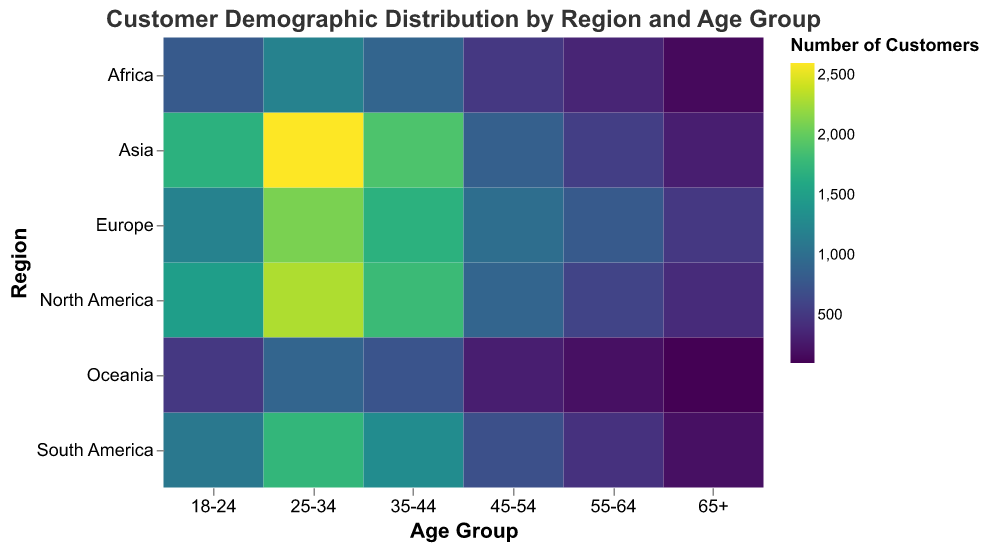What is the title of the heatmap? The title is located at the top of the heatmap and reads "Customer Demographic Distribution by Region and Age Group".
Answer: Customer Demographic Distribution by Region and Age Group Which region has the highest number of customers for the 25-34 age group? By looking at the intersection of the '25-34' age group and different regions on the y-axis, Asia has the darkest shade, indicating the highest number of customers for this age group.
Answer: Asia How many customers are in the 45-54 age group for Europe? To find this, locate the cell where the '45-54' age group column intersects with the 'Europe' row. The number in the cell is 1000.
Answer: 1000 Among the different regions, which has the smallest number of customers in the 65+ age group? By locating the '65+' column and comparing shades across the regions, Oceania has the lightest shade, indicating the smallest number of customers, which is 100.
Answer: Oceania What is the total number of customers for the 18-24 age group across all regions? Sum the number of customers for the '18-24' age group from each region: 1500 (North America) + 1200 (Europe) + 1700 (Asia) + 1100 (South America) + 800 (Africa) + 500 (Oceania) = 6800.
Answer: 6800 Which age group in North America has the fewest customers? Check the 'North America' row and identify the age group with the lightest shade. The '65+' age group has the fewest customers with 400.
Answer: 65+ Compare the number of customers in the 25-34 age group between Africa and South America. Which region has more customers? Compare the numbers in the '25-34' column for Africa (1200) and South America (1750). South America has more customers.
Answer: South America What is the average number of customers for the 35-44 age group across Asia, Europe, and North America? Sum the number of customers for the '35-44' age group in Asia (1900), Europe (1700), and North America (1800). The total is 5400. Then divide by 3: 5400 / 3 = 1800.
Answer: 1800 What is the trend in the number of customers as age increases in South America? Observe the cells in the 'South America' row from left to right. Generally, the number of customers decreases as age increases.
Answer: Decreasing Which age group has the highest number of customers in Asia, and how many? Identify the darkest cell in the 'Asia' row; the '25-34' age group has the highest number of customers, with 2600.
Answer: 25-34, 2600 